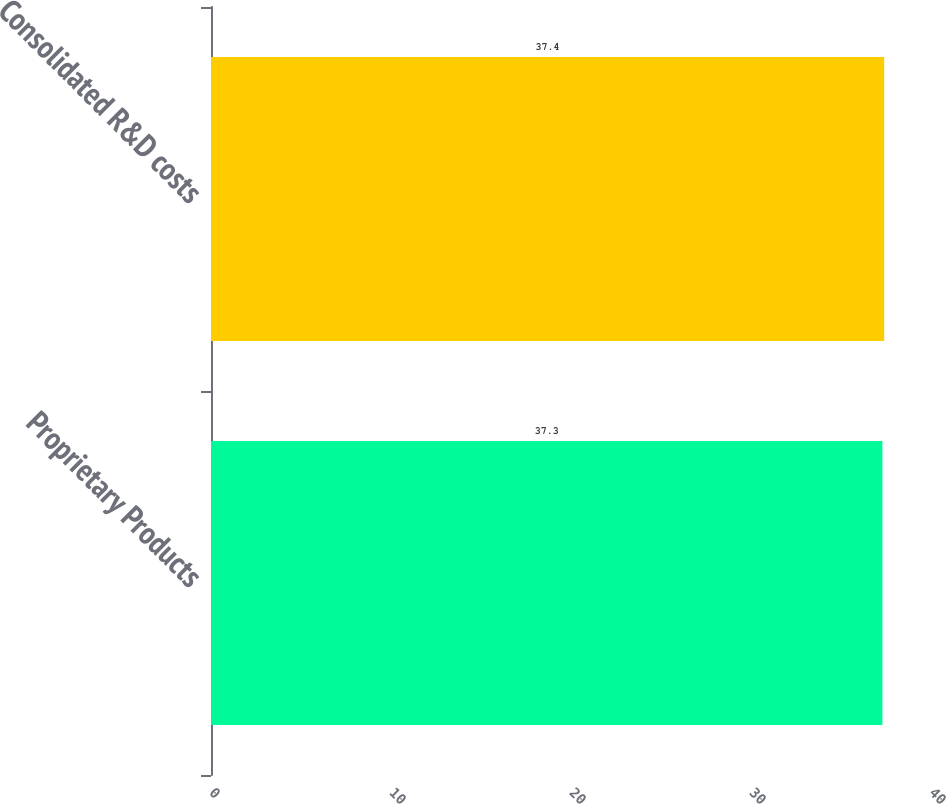Convert chart to OTSL. <chart><loc_0><loc_0><loc_500><loc_500><bar_chart><fcel>Proprietary Products<fcel>Consolidated R&D costs<nl><fcel>37.3<fcel>37.4<nl></chart> 